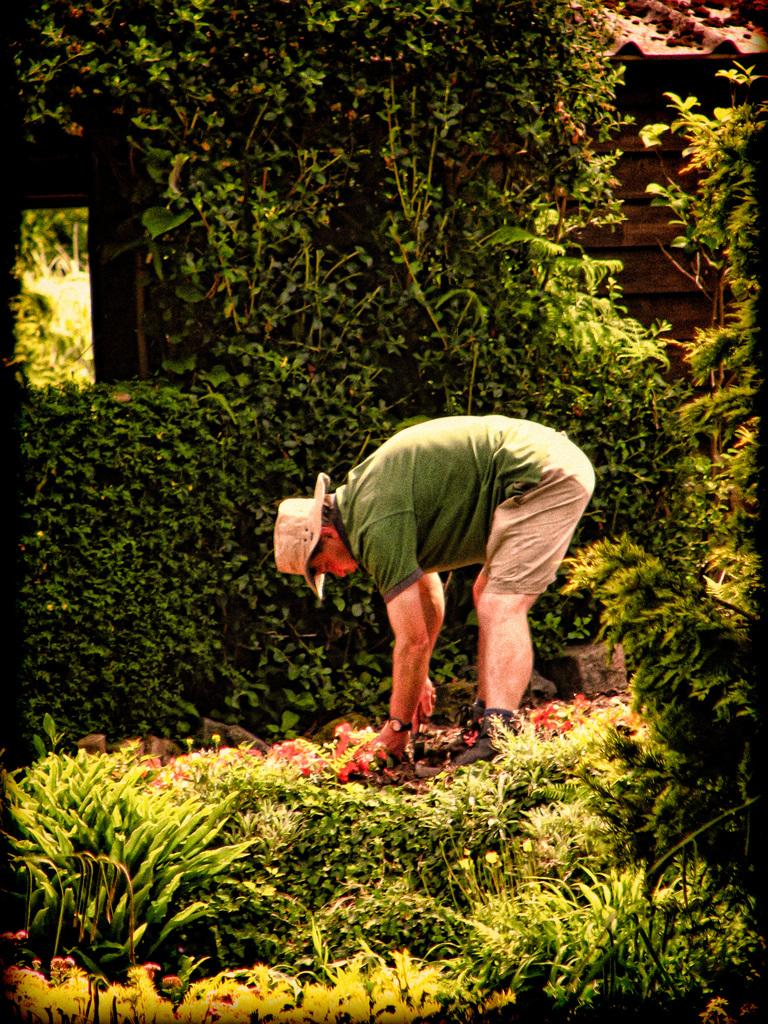Who is present in the image? There is a person in the image. What is the person wearing on their head? The person is wearing a cap. What is the person holding in the image? The person is holding an object. What type of vegetation can be seen in the image? There are plants in the image. What is the cause of the person's hearing loss in the image? There is no indication of hearing loss in the image, and therefore no cause can be determined. 